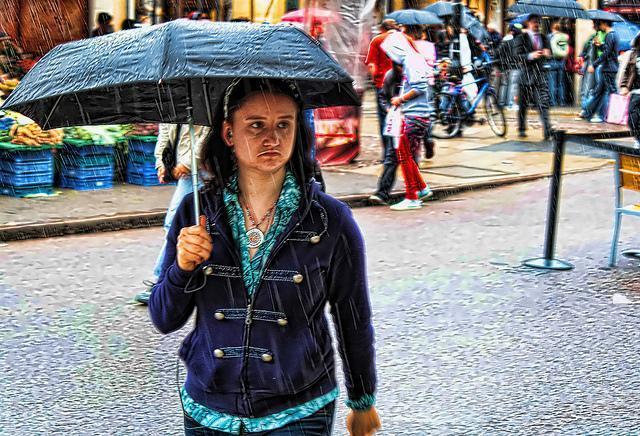How many people are in the picture?
Give a very brief answer. 5. How many donuts are there?
Give a very brief answer. 0. 